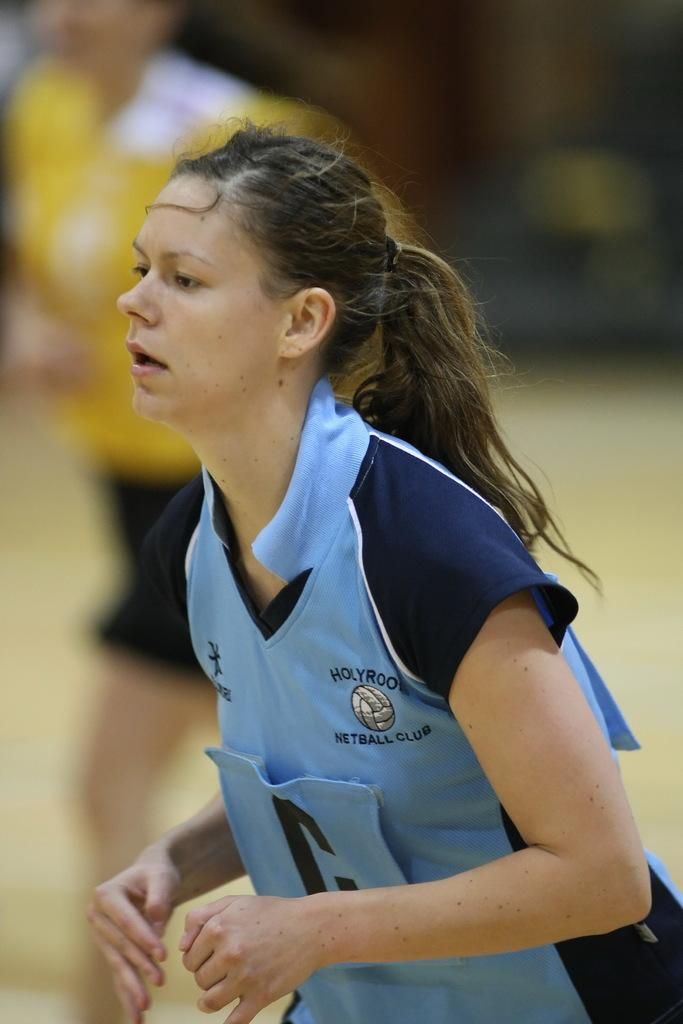<image>
Provide a brief description of the given image. A woman in a netball club jersey has her hair in a ponytail 